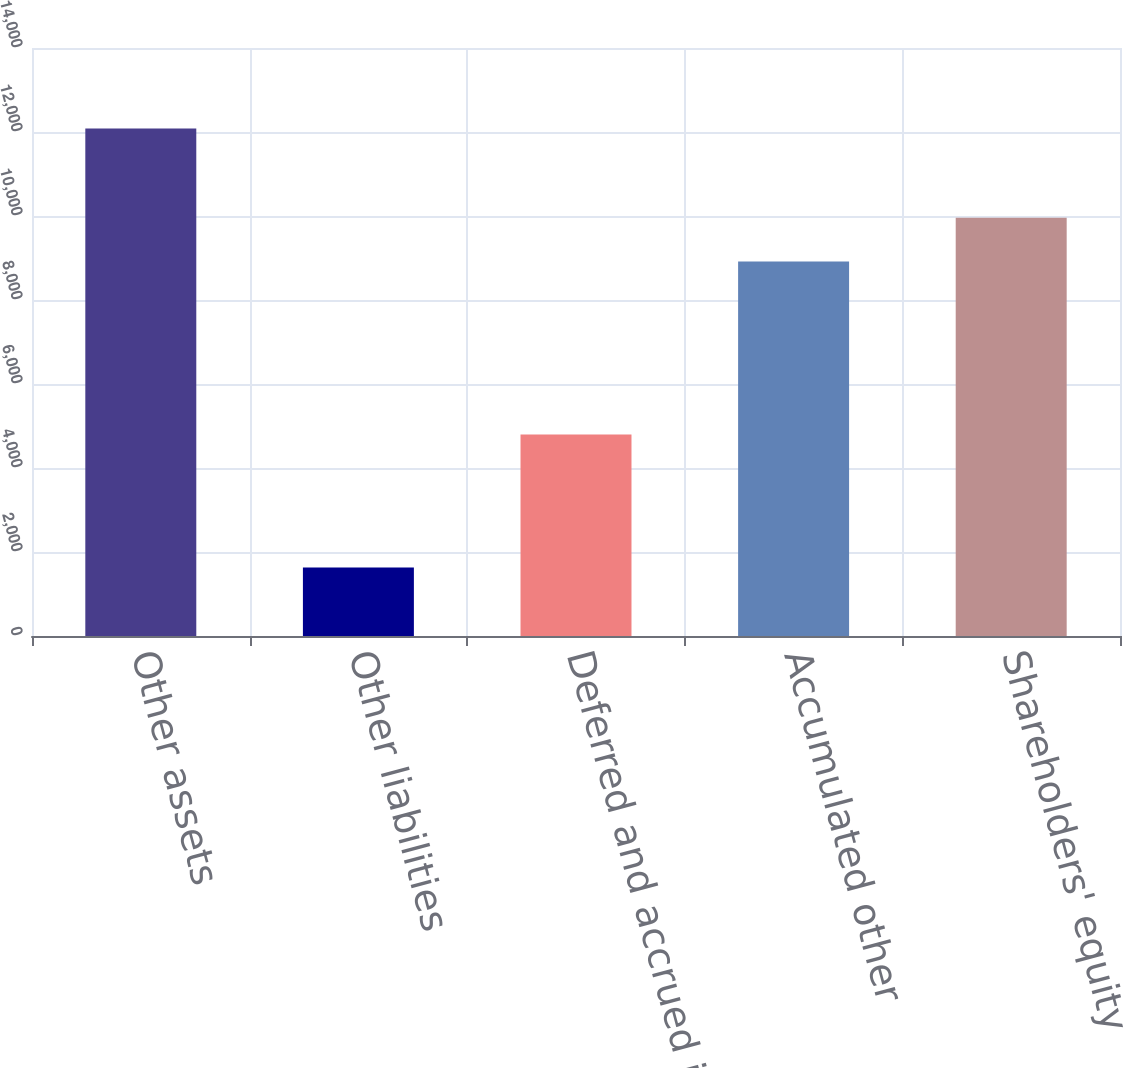<chart> <loc_0><loc_0><loc_500><loc_500><bar_chart><fcel>Other assets<fcel>Other liabilities<fcel>Deferred and accrued income<fcel>Accumulated other<fcel>Shareholders' equity<nl><fcel>12083<fcel>1632<fcel>4800<fcel>8915<fcel>9960.1<nl></chart> 